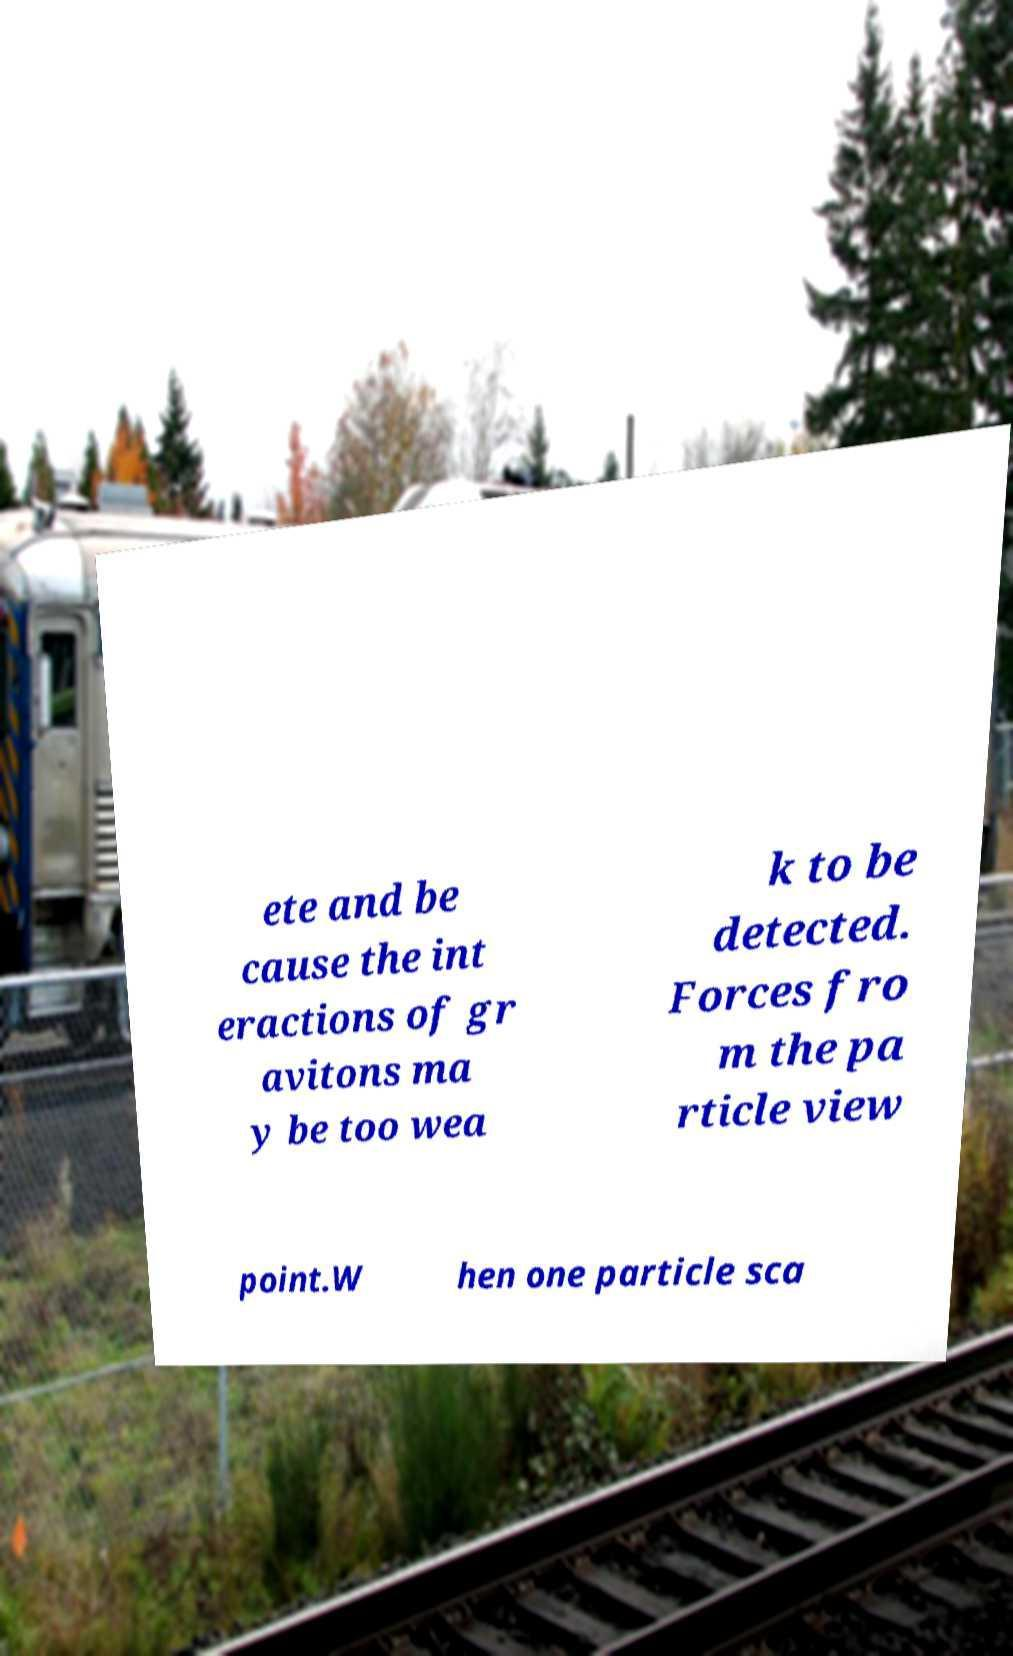Could you extract and type out the text from this image? ete and be cause the int eractions of gr avitons ma y be too wea k to be detected. Forces fro m the pa rticle view point.W hen one particle sca 